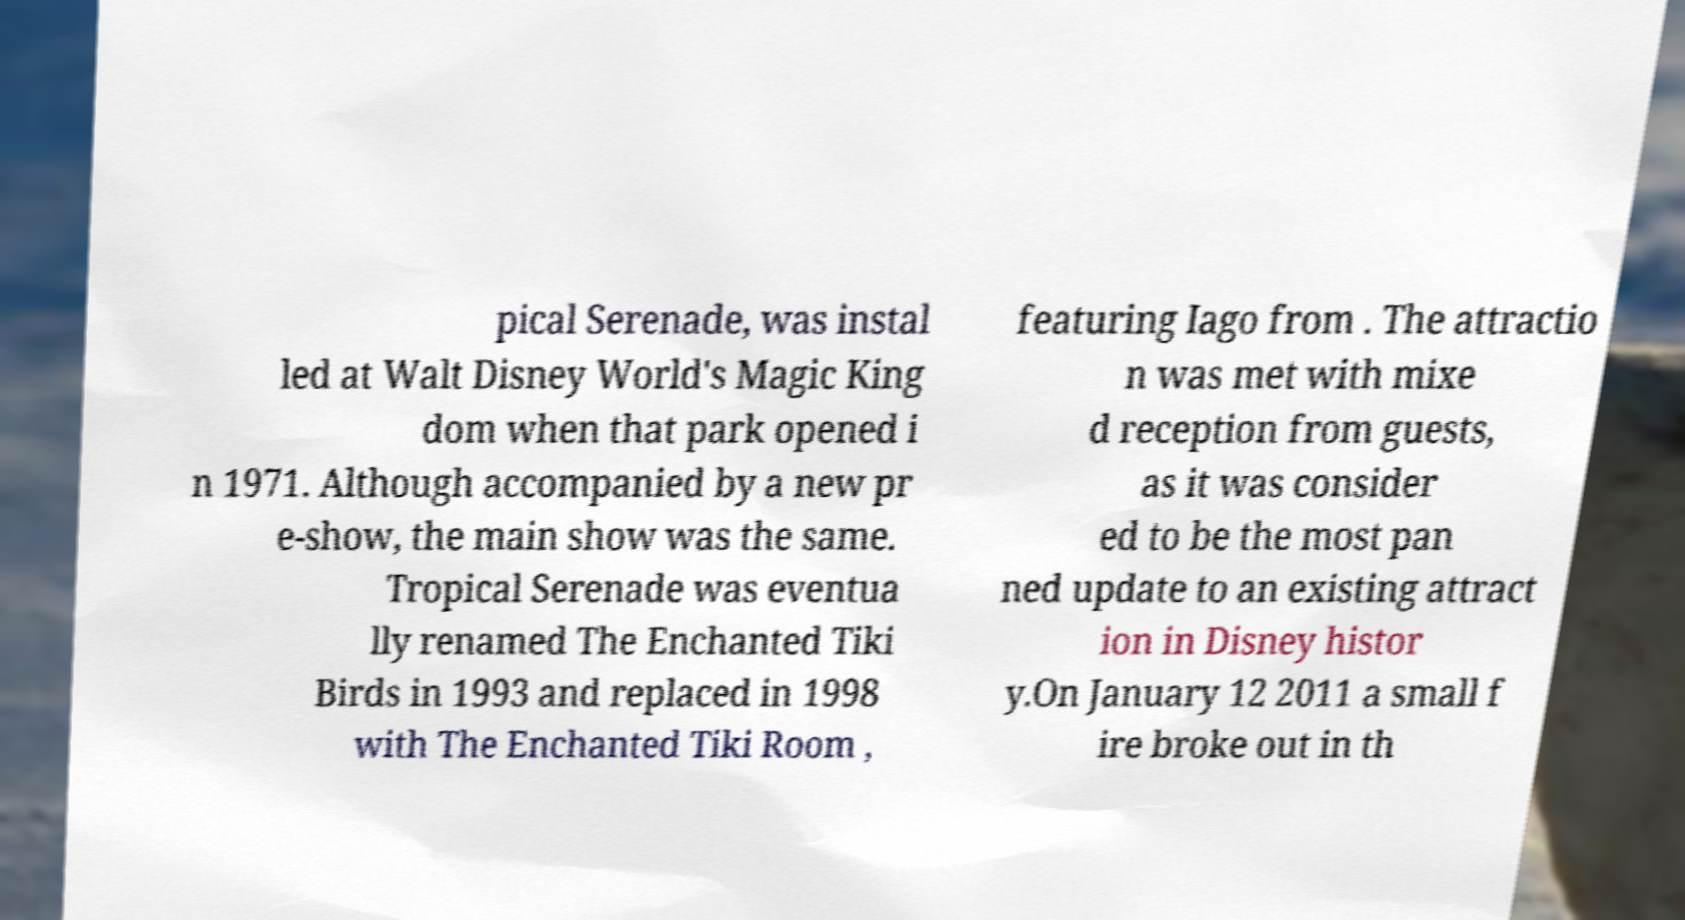Please identify and transcribe the text found in this image. pical Serenade, was instal led at Walt Disney World's Magic King dom when that park opened i n 1971. Although accompanied by a new pr e-show, the main show was the same. Tropical Serenade was eventua lly renamed The Enchanted Tiki Birds in 1993 and replaced in 1998 with The Enchanted Tiki Room , featuring Iago from . The attractio n was met with mixe d reception from guests, as it was consider ed to be the most pan ned update to an existing attract ion in Disney histor y.On January 12 2011 a small f ire broke out in th 